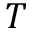Convert formula to latex. <formula><loc_0><loc_0><loc_500><loc_500>T</formula> 